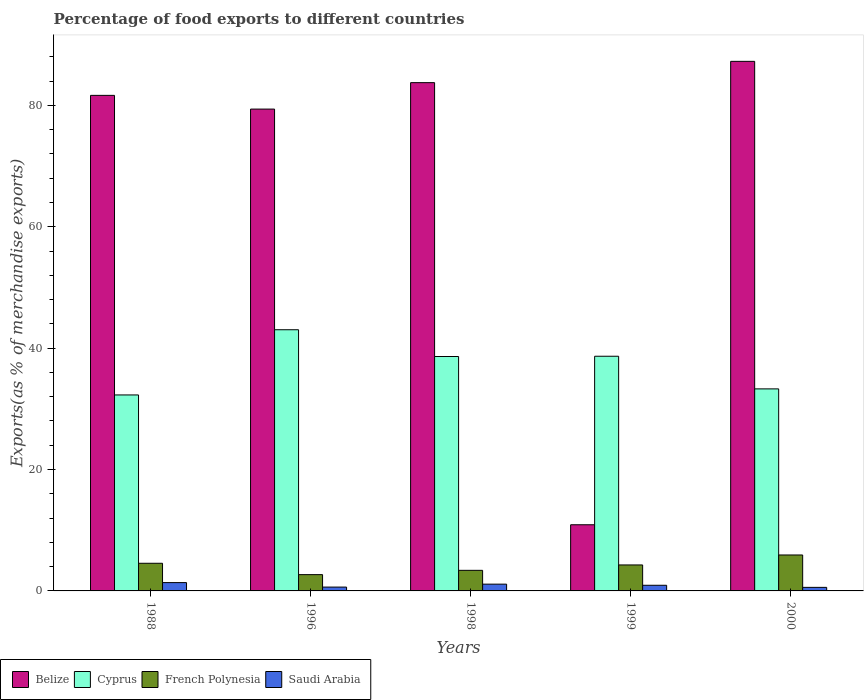How many groups of bars are there?
Provide a short and direct response. 5. Are the number of bars on each tick of the X-axis equal?
Provide a succinct answer. Yes. How many bars are there on the 4th tick from the left?
Make the answer very short. 4. How many bars are there on the 2nd tick from the right?
Provide a succinct answer. 4. What is the label of the 5th group of bars from the left?
Your response must be concise. 2000. What is the percentage of exports to different countries in Cyprus in 1998?
Ensure brevity in your answer.  38.62. Across all years, what is the maximum percentage of exports to different countries in Saudi Arabia?
Ensure brevity in your answer.  1.37. Across all years, what is the minimum percentage of exports to different countries in French Polynesia?
Make the answer very short. 2.68. In which year was the percentage of exports to different countries in Saudi Arabia maximum?
Your answer should be very brief. 1988. In which year was the percentage of exports to different countries in Saudi Arabia minimum?
Offer a very short reply. 2000. What is the total percentage of exports to different countries in Cyprus in the graph?
Your response must be concise. 185.91. What is the difference between the percentage of exports to different countries in Saudi Arabia in 1998 and that in 2000?
Your response must be concise. 0.53. What is the difference between the percentage of exports to different countries in French Polynesia in 1988 and the percentage of exports to different countries in Cyprus in 1998?
Keep it short and to the point. -34.07. What is the average percentage of exports to different countries in Belize per year?
Keep it short and to the point. 68.59. In the year 2000, what is the difference between the percentage of exports to different countries in French Polynesia and percentage of exports to different countries in Cyprus?
Ensure brevity in your answer.  -27.37. In how many years, is the percentage of exports to different countries in Belize greater than 80 %?
Make the answer very short. 3. What is the ratio of the percentage of exports to different countries in Saudi Arabia in 1988 to that in 1998?
Ensure brevity in your answer.  1.23. Is the difference between the percentage of exports to different countries in French Polynesia in 1998 and 1999 greater than the difference between the percentage of exports to different countries in Cyprus in 1998 and 1999?
Ensure brevity in your answer.  No. What is the difference between the highest and the second highest percentage of exports to different countries in Cyprus?
Keep it short and to the point. 4.37. What is the difference between the highest and the lowest percentage of exports to different countries in Saudi Arabia?
Your answer should be compact. 0.78. In how many years, is the percentage of exports to different countries in Saudi Arabia greater than the average percentage of exports to different countries in Saudi Arabia taken over all years?
Your answer should be compact. 3. Is the sum of the percentage of exports to different countries in Cyprus in 1988 and 1998 greater than the maximum percentage of exports to different countries in Saudi Arabia across all years?
Make the answer very short. Yes. What does the 4th bar from the left in 1996 represents?
Your answer should be very brief. Saudi Arabia. What does the 2nd bar from the right in 1988 represents?
Keep it short and to the point. French Polynesia. Is it the case that in every year, the sum of the percentage of exports to different countries in Saudi Arabia and percentage of exports to different countries in French Polynesia is greater than the percentage of exports to different countries in Belize?
Your answer should be compact. No. How many bars are there?
Provide a short and direct response. 20. Are all the bars in the graph horizontal?
Provide a succinct answer. No. How many years are there in the graph?
Your response must be concise. 5. Does the graph contain any zero values?
Make the answer very short. No. Does the graph contain grids?
Offer a terse response. No. Where does the legend appear in the graph?
Provide a succinct answer. Bottom left. How many legend labels are there?
Your answer should be compact. 4. How are the legend labels stacked?
Your response must be concise. Horizontal. What is the title of the graph?
Offer a very short reply. Percentage of food exports to different countries. Does "Arab World" appear as one of the legend labels in the graph?
Make the answer very short. No. What is the label or title of the X-axis?
Offer a terse response. Years. What is the label or title of the Y-axis?
Ensure brevity in your answer.  Exports(as % of merchandise exports). What is the Exports(as % of merchandise exports) in Belize in 1988?
Keep it short and to the point. 81.65. What is the Exports(as % of merchandise exports) in Cyprus in 1988?
Offer a terse response. 32.29. What is the Exports(as % of merchandise exports) in French Polynesia in 1988?
Your answer should be very brief. 4.56. What is the Exports(as % of merchandise exports) of Saudi Arabia in 1988?
Your response must be concise. 1.37. What is the Exports(as % of merchandise exports) of Belize in 1996?
Your answer should be very brief. 79.39. What is the Exports(as % of merchandise exports) in Cyprus in 1996?
Make the answer very short. 43.04. What is the Exports(as % of merchandise exports) of French Polynesia in 1996?
Provide a succinct answer. 2.68. What is the Exports(as % of merchandise exports) of Saudi Arabia in 1996?
Your answer should be compact. 0.63. What is the Exports(as % of merchandise exports) in Belize in 1998?
Offer a terse response. 83.75. What is the Exports(as % of merchandise exports) in Cyprus in 1998?
Your answer should be very brief. 38.62. What is the Exports(as % of merchandise exports) of French Polynesia in 1998?
Make the answer very short. 3.39. What is the Exports(as % of merchandise exports) of Saudi Arabia in 1998?
Offer a very short reply. 1.11. What is the Exports(as % of merchandise exports) in Belize in 1999?
Your answer should be very brief. 10.9. What is the Exports(as % of merchandise exports) of Cyprus in 1999?
Offer a very short reply. 38.67. What is the Exports(as % of merchandise exports) of French Polynesia in 1999?
Give a very brief answer. 4.28. What is the Exports(as % of merchandise exports) in Saudi Arabia in 1999?
Keep it short and to the point. 0.93. What is the Exports(as % of merchandise exports) of Belize in 2000?
Keep it short and to the point. 87.26. What is the Exports(as % of merchandise exports) in Cyprus in 2000?
Make the answer very short. 33.29. What is the Exports(as % of merchandise exports) of French Polynesia in 2000?
Provide a succinct answer. 5.92. What is the Exports(as % of merchandise exports) in Saudi Arabia in 2000?
Give a very brief answer. 0.59. Across all years, what is the maximum Exports(as % of merchandise exports) of Belize?
Ensure brevity in your answer.  87.26. Across all years, what is the maximum Exports(as % of merchandise exports) in Cyprus?
Your answer should be compact. 43.04. Across all years, what is the maximum Exports(as % of merchandise exports) in French Polynesia?
Give a very brief answer. 5.92. Across all years, what is the maximum Exports(as % of merchandise exports) of Saudi Arabia?
Your answer should be compact. 1.37. Across all years, what is the minimum Exports(as % of merchandise exports) in Belize?
Ensure brevity in your answer.  10.9. Across all years, what is the minimum Exports(as % of merchandise exports) of Cyprus?
Give a very brief answer. 32.29. Across all years, what is the minimum Exports(as % of merchandise exports) in French Polynesia?
Offer a terse response. 2.68. Across all years, what is the minimum Exports(as % of merchandise exports) of Saudi Arabia?
Keep it short and to the point. 0.59. What is the total Exports(as % of merchandise exports) of Belize in the graph?
Offer a terse response. 342.96. What is the total Exports(as % of merchandise exports) in Cyprus in the graph?
Make the answer very short. 185.91. What is the total Exports(as % of merchandise exports) in French Polynesia in the graph?
Your answer should be compact. 20.84. What is the total Exports(as % of merchandise exports) in Saudi Arabia in the graph?
Make the answer very short. 4.64. What is the difference between the Exports(as % of merchandise exports) in Belize in 1988 and that in 1996?
Provide a short and direct response. 2.26. What is the difference between the Exports(as % of merchandise exports) of Cyprus in 1988 and that in 1996?
Give a very brief answer. -10.74. What is the difference between the Exports(as % of merchandise exports) of French Polynesia in 1988 and that in 1996?
Give a very brief answer. 1.87. What is the difference between the Exports(as % of merchandise exports) of Saudi Arabia in 1988 and that in 1996?
Your response must be concise. 0.74. What is the difference between the Exports(as % of merchandise exports) of Belize in 1988 and that in 1998?
Keep it short and to the point. -2.1. What is the difference between the Exports(as % of merchandise exports) of Cyprus in 1988 and that in 1998?
Your answer should be compact. -6.33. What is the difference between the Exports(as % of merchandise exports) of French Polynesia in 1988 and that in 1998?
Offer a very short reply. 1.16. What is the difference between the Exports(as % of merchandise exports) in Saudi Arabia in 1988 and that in 1998?
Provide a short and direct response. 0.26. What is the difference between the Exports(as % of merchandise exports) in Belize in 1988 and that in 1999?
Your response must be concise. 70.75. What is the difference between the Exports(as % of merchandise exports) in Cyprus in 1988 and that in 1999?
Make the answer very short. -6.38. What is the difference between the Exports(as % of merchandise exports) in French Polynesia in 1988 and that in 1999?
Give a very brief answer. 0.27. What is the difference between the Exports(as % of merchandise exports) in Saudi Arabia in 1988 and that in 1999?
Make the answer very short. 0.44. What is the difference between the Exports(as % of merchandise exports) of Belize in 1988 and that in 2000?
Ensure brevity in your answer.  -5.61. What is the difference between the Exports(as % of merchandise exports) of Cyprus in 1988 and that in 2000?
Offer a very short reply. -1. What is the difference between the Exports(as % of merchandise exports) of French Polynesia in 1988 and that in 2000?
Offer a very short reply. -1.37. What is the difference between the Exports(as % of merchandise exports) in Saudi Arabia in 1988 and that in 2000?
Provide a succinct answer. 0.78. What is the difference between the Exports(as % of merchandise exports) in Belize in 1996 and that in 1998?
Give a very brief answer. -4.36. What is the difference between the Exports(as % of merchandise exports) of Cyprus in 1996 and that in 1998?
Offer a terse response. 4.41. What is the difference between the Exports(as % of merchandise exports) in French Polynesia in 1996 and that in 1998?
Your answer should be compact. -0.71. What is the difference between the Exports(as % of merchandise exports) in Saudi Arabia in 1996 and that in 1998?
Make the answer very short. -0.48. What is the difference between the Exports(as % of merchandise exports) of Belize in 1996 and that in 1999?
Give a very brief answer. 68.49. What is the difference between the Exports(as % of merchandise exports) in Cyprus in 1996 and that in 1999?
Your response must be concise. 4.37. What is the difference between the Exports(as % of merchandise exports) of French Polynesia in 1996 and that in 1999?
Offer a very short reply. -1.6. What is the difference between the Exports(as % of merchandise exports) in Saudi Arabia in 1996 and that in 1999?
Keep it short and to the point. -0.3. What is the difference between the Exports(as % of merchandise exports) of Belize in 1996 and that in 2000?
Make the answer very short. -7.87. What is the difference between the Exports(as % of merchandise exports) of Cyprus in 1996 and that in 2000?
Provide a succinct answer. 9.74. What is the difference between the Exports(as % of merchandise exports) of French Polynesia in 1996 and that in 2000?
Provide a short and direct response. -3.24. What is the difference between the Exports(as % of merchandise exports) in Saudi Arabia in 1996 and that in 2000?
Your answer should be compact. 0.05. What is the difference between the Exports(as % of merchandise exports) of Belize in 1998 and that in 1999?
Offer a terse response. 72.85. What is the difference between the Exports(as % of merchandise exports) in Cyprus in 1998 and that in 1999?
Your response must be concise. -0.05. What is the difference between the Exports(as % of merchandise exports) in French Polynesia in 1998 and that in 1999?
Make the answer very short. -0.89. What is the difference between the Exports(as % of merchandise exports) in Saudi Arabia in 1998 and that in 1999?
Provide a succinct answer. 0.18. What is the difference between the Exports(as % of merchandise exports) of Belize in 1998 and that in 2000?
Your answer should be very brief. -3.51. What is the difference between the Exports(as % of merchandise exports) in Cyprus in 1998 and that in 2000?
Provide a short and direct response. 5.33. What is the difference between the Exports(as % of merchandise exports) in French Polynesia in 1998 and that in 2000?
Ensure brevity in your answer.  -2.53. What is the difference between the Exports(as % of merchandise exports) of Saudi Arabia in 1998 and that in 2000?
Keep it short and to the point. 0.53. What is the difference between the Exports(as % of merchandise exports) of Belize in 1999 and that in 2000?
Provide a succinct answer. -76.36. What is the difference between the Exports(as % of merchandise exports) in Cyprus in 1999 and that in 2000?
Provide a short and direct response. 5.38. What is the difference between the Exports(as % of merchandise exports) of French Polynesia in 1999 and that in 2000?
Provide a short and direct response. -1.64. What is the difference between the Exports(as % of merchandise exports) of Saudi Arabia in 1999 and that in 2000?
Your answer should be very brief. 0.34. What is the difference between the Exports(as % of merchandise exports) of Belize in 1988 and the Exports(as % of merchandise exports) of Cyprus in 1996?
Your response must be concise. 38.62. What is the difference between the Exports(as % of merchandise exports) of Belize in 1988 and the Exports(as % of merchandise exports) of French Polynesia in 1996?
Ensure brevity in your answer.  78.97. What is the difference between the Exports(as % of merchandise exports) of Belize in 1988 and the Exports(as % of merchandise exports) of Saudi Arabia in 1996?
Keep it short and to the point. 81.02. What is the difference between the Exports(as % of merchandise exports) in Cyprus in 1988 and the Exports(as % of merchandise exports) in French Polynesia in 1996?
Your response must be concise. 29.61. What is the difference between the Exports(as % of merchandise exports) of Cyprus in 1988 and the Exports(as % of merchandise exports) of Saudi Arabia in 1996?
Your answer should be compact. 31.66. What is the difference between the Exports(as % of merchandise exports) in French Polynesia in 1988 and the Exports(as % of merchandise exports) in Saudi Arabia in 1996?
Keep it short and to the point. 3.92. What is the difference between the Exports(as % of merchandise exports) of Belize in 1988 and the Exports(as % of merchandise exports) of Cyprus in 1998?
Your answer should be compact. 43.03. What is the difference between the Exports(as % of merchandise exports) in Belize in 1988 and the Exports(as % of merchandise exports) in French Polynesia in 1998?
Offer a very short reply. 78.26. What is the difference between the Exports(as % of merchandise exports) of Belize in 1988 and the Exports(as % of merchandise exports) of Saudi Arabia in 1998?
Your answer should be compact. 80.54. What is the difference between the Exports(as % of merchandise exports) of Cyprus in 1988 and the Exports(as % of merchandise exports) of French Polynesia in 1998?
Offer a very short reply. 28.9. What is the difference between the Exports(as % of merchandise exports) in Cyprus in 1988 and the Exports(as % of merchandise exports) in Saudi Arabia in 1998?
Ensure brevity in your answer.  31.18. What is the difference between the Exports(as % of merchandise exports) in French Polynesia in 1988 and the Exports(as % of merchandise exports) in Saudi Arabia in 1998?
Offer a very short reply. 3.44. What is the difference between the Exports(as % of merchandise exports) of Belize in 1988 and the Exports(as % of merchandise exports) of Cyprus in 1999?
Offer a very short reply. 42.98. What is the difference between the Exports(as % of merchandise exports) of Belize in 1988 and the Exports(as % of merchandise exports) of French Polynesia in 1999?
Make the answer very short. 77.37. What is the difference between the Exports(as % of merchandise exports) of Belize in 1988 and the Exports(as % of merchandise exports) of Saudi Arabia in 1999?
Your answer should be compact. 80.72. What is the difference between the Exports(as % of merchandise exports) in Cyprus in 1988 and the Exports(as % of merchandise exports) in French Polynesia in 1999?
Provide a short and direct response. 28.01. What is the difference between the Exports(as % of merchandise exports) in Cyprus in 1988 and the Exports(as % of merchandise exports) in Saudi Arabia in 1999?
Your answer should be compact. 31.36. What is the difference between the Exports(as % of merchandise exports) of French Polynesia in 1988 and the Exports(as % of merchandise exports) of Saudi Arabia in 1999?
Your answer should be compact. 3.62. What is the difference between the Exports(as % of merchandise exports) in Belize in 1988 and the Exports(as % of merchandise exports) in Cyprus in 2000?
Keep it short and to the point. 48.36. What is the difference between the Exports(as % of merchandise exports) in Belize in 1988 and the Exports(as % of merchandise exports) in French Polynesia in 2000?
Your response must be concise. 75.73. What is the difference between the Exports(as % of merchandise exports) in Belize in 1988 and the Exports(as % of merchandise exports) in Saudi Arabia in 2000?
Your answer should be compact. 81.07. What is the difference between the Exports(as % of merchandise exports) of Cyprus in 1988 and the Exports(as % of merchandise exports) of French Polynesia in 2000?
Keep it short and to the point. 26.37. What is the difference between the Exports(as % of merchandise exports) in Cyprus in 1988 and the Exports(as % of merchandise exports) in Saudi Arabia in 2000?
Your response must be concise. 31.71. What is the difference between the Exports(as % of merchandise exports) of French Polynesia in 1988 and the Exports(as % of merchandise exports) of Saudi Arabia in 2000?
Ensure brevity in your answer.  3.97. What is the difference between the Exports(as % of merchandise exports) in Belize in 1996 and the Exports(as % of merchandise exports) in Cyprus in 1998?
Your answer should be very brief. 40.77. What is the difference between the Exports(as % of merchandise exports) in Belize in 1996 and the Exports(as % of merchandise exports) in French Polynesia in 1998?
Provide a short and direct response. 76. What is the difference between the Exports(as % of merchandise exports) in Belize in 1996 and the Exports(as % of merchandise exports) in Saudi Arabia in 1998?
Provide a succinct answer. 78.28. What is the difference between the Exports(as % of merchandise exports) of Cyprus in 1996 and the Exports(as % of merchandise exports) of French Polynesia in 1998?
Ensure brevity in your answer.  39.64. What is the difference between the Exports(as % of merchandise exports) in Cyprus in 1996 and the Exports(as % of merchandise exports) in Saudi Arabia in 1998?
Make the answer very short. 41.92. What is the difference between the Exports(as % of merchandise exports) of French Polynesia in 1996 and the Exports(as % of merchandise exports) of Saudi Arabia in 1998?
Keep it short and to the point. 1.57. What is the difference between the Exports(as % of merchandise exports) of Belize in 1996 and the Exports(as % of merchandise exports) of Cyprus in 1999?
Provide a short and direct response. 40.72. What is the difference between the Exports(as % of merchandise exports) of Belize in 1996 and the Exports(as % of merchandise exports) of French Polynesia in 1999?
Provide a succinct answer. 75.11. What is the difference between the Exports(as % of merchandise exports) in Belize in 1996 and the Exports(as % of merchandise exports) in Saudi Arabia in 1999?
Your response must be concise. 78.46. What is the difference between the Exports(as % of merchandise exports) in Cyprus in 1996 and the Exports(as % of merchandise exports) in French Polynesia in 1999?
Provide a short and direct response. 38.75. What is the difference between the Exports(as % of merchandise exports) of Cyprus in 1996 and the Exports(as % of merchandise exports) of Saudi Arabia in 1999?
Your answer should be compact. 42.1. What is the difference between the Exports(as % of merchandise exports) in French Polynesia in 1996 and the Exports(as % of merchandise exports) in Saudi Arabia in 1999?
Ensure brevity in your answer.  1.75. What is the difference between the Exports(as % of merchandise exports) of Belize in 1996 and the Exports(as % of merchandise exports) of Cyprus in 2000?
Give a very brief answer. 46.1. What is the difference between the Exports(as % of merchandise exports) of Belize in 1996 and the Exports(as % of merchandise exports) of French Polynesia in 2000?
Make the answer very short. 73.47. What is the difference between the Exports(as % of merchandise exports) of Belize in 1996 and the Exports(as % of merchandise exports) of Saudi Arabia in 2000?
Keep it short and to the point. 78.81. What is the difference between the Exports(as % of merchandise exports) of Cyprus in 1996 and the Exports(as % of merchandise exports) of French Polynesia in 2000?
Give a very brief answer. 37.11. What is the difference between the Exports(as % of merchandise exports) of Cyprus in 1996 and the Exports(as % of merchandise exports) of Saudi Arabia in 2000?
Your answer should be compact. 42.45. What is the difference between the Exports(as % of merchandise exports) in French Polynesia in 1996 and the Exports(as % of merchandise exports) in Saudi Arabia in 2000?
Provide a short and direct response. 2.1. What is the difference between the Exports(as % of merchandise exports) in Belize in 1998 and the Exports(as % of merchandise exports) in Cyprus in 1999?
Your answer should be compact. 45.08. What is the difference between the Exports(as % of merchandise exports) in Belize in 1998 and the Exports(as % of merchandise exports) in French Polynesia in 1999?
Your answer should be very brief. 79.47. What is the difference between the Exports(as % of merchandise exports) in Belize in 1998 and the Exports(as % of merchandise exports) in Saudi Arabia in 1999?
Offer a terse response. 82.82. What is the difference between the Exports(as % of merchandise exports) of Cyprus in 1998 and the Exports(as % of merchandise exports) of French Polynesia in 1999?
Offer a very short reply. 34.34. What is the difference between the Exports(as % of merchandise exports) in Cyprus in 1998 and the Exports(as % of merchandise exports) in Saudi Arabia in 1999?
Provide a succinct answer. 37.69. What is the difference between the Exports(as % of merchandise exports) of French Polynesia in 1998 and the Exports(as % of merchandise exports) of Saudi Arabia in 1999?
Your answer should be compact. 2.46. What is the difference between the Exports(as % of merchandise exports) in Belize in 1998 and the Exports(as % of merchandise exports) in Cyprus in 2000?
Keep it short and to the point. 50.46. What is the difference between the Exports(as % of merchandise exports) of Belize in 1998 and the Exports(as % of merchandise exports) of French Polynesia in 2000?
Offer a terse response. 77.83. What is the difference between the Exports(as % of merchandise exports) of Belize in 1998 and the Exports(as % of merchandise exports) of Saudi Arabia in 2000?
Provide a succinct answer. 83.16. What is the difference between the Exports(as % of merchandise exports) in Cyprus in 1998 and the Exports(as % of merchandise exports) in French Polynesia in 2000?
Your answer should be very brief. 32.7. What is the difference between the Exports(as % of merchandise exports) in Cyprus in 1998 and the Exports(as % of merchandise exports) in Saudi Arabia in 2000?
Provide a succinct answer. 38.04. What is the difference between the Exports(as % of merchandise exports) of French Polynesia in 1998 and the Exports(as % of merchandise exports) of Saudi Arabia in 2000?
Make the answer very short. 2.81. What is the difference between the Exports(as % of merchandise exports) of Belize in 1999 and the Exports(as % of merchandise exports) of Cyprus in 2000?
Your answer should be compact. -22.39. What is the difference between the Exports(as % of merchandise exports) of Belize in 1999 and the Exports(as % of merchandise exports) of French Polynesia in 2000?
Ensure brevity in your answer.  4.98. What is the difference between the Exports(as % of merchandise exports) in Belize in 1999 and the Exports(as % of merchandise exports) in Saudi Arabia in 2000?
Ensure brevity in your answer.  10.32. What is the difference between the Exports(as % of merchandise exports) of Cyprus in 1999 and the Exports(as % of merchandise exports) of French Polynesia in 2000?
Keep it short and to the point. 32.75. What is the difference between the Exports(as % of merchandise exports) in Cyprus in 1999 and the Exports(as % of merchandise exports) in Saudi Arabia in 2000?
Your answer should be compact. 38.08. What is the difference between the Exports(as % of merchandise exports) of French Polynesia in 1999 and the Exports(as % of merchandise exports) of Saudi Arabia in 2000?
Provide a succinct answer. 3.69. What is the average Exports(as % of merchandise exports) of Belize per year?
Keep it short and to the point. 68.59. What is the average Exports(as % of merchandise exports) of Cyprus per year?
Provide a succinct answer. 37.18. What is the average Exports(as % of merchandise exports) in French Polynesia per year?
Offer a terse response. 4.17. What is the average Exports(as % of merchandise exports) in Saudi Arabia per year?
Give a very brief answer. 0.93. In the year 1988, what is the difference between the Exports(as % of merchandise exports) in Belize and Exports(as % of merchandise exports) in Cyprus?
Provide a short and direct response. 49.36. In the year 1988, what is the difference between the Exports(as % of merchandise exports) in Belize and Exports(as % of merchandise exports) in French Polynesia?
Make the answer very short. 77.1. In the year 1988, what is the difference between the Exports(as % of merchandise exports) of Belize and Exports(as % of merchandise exports) of Saudi Arabia?
Provide a succinct answer. 80.28. In the year 1988, what is the difference between the Exports(as % of merchandise exports) in Cyprus and Exports(as % of merchandise exports) in French Polynesia?
Make the answer very short. 27.74. In the year 1988, what is the difference between the Exports(as % of merchandise exports) of Cyprus and Exports(as % of merchandise exports) of Saudi Arabia?
Make the answer very short. 30.92. In the year 1988, what is the difference between the Exports(as % of merchandise exports) of French Polynesia and Exports(as % of merchandise exports) of Saudi Arabia?
Your answer should be very brief. 3.18. In the year 1996, what is the difference between the Exports(as % of merchandise exports) in Belize and Exports(as % of merchandise exports) in Cyprus?
Your answer should be very brief. 36.36. In the year 1996, what is the difference between the Exports(as % of merchandise exports) of Belize and Exports(as % of merchandise exports) of French Polynesia?
Provide a short and direct response. 76.71. In the year 1996, what is the difference between the Exports(as % of merchandise exports) of Belize and Exports(as % of merchandise exports) of Saudi Arabia?
Give a very brief answer. 78.76. In the year 1996, what is the difference between the Exports(as % of merchandise exports) in Cyprus and Exports(as % of merchandise exports) in French Polynesia?
Keep it short and to the point. 40.35. In the year 1996, what is the difference between the Exports(as % of merchandise exports) of Cyprus and Exports(as % of merchandise exports) of Saudi Arabia?
Provide a short and direct response. 42.4. In the year 1996, what is the difference between the Exports(as % of merchandise exports) of French Polynesia and Exports(as % of merchandise exports) of Saudi Arabia?
Offer a very short reply. 2.05. In the year 1998, what is the difference between the Exports(as % of merchandise exports) of Belize and Exports(as % of merchandise exports) of Cyprus?
Offer a very short reply. 45.12. In the year 1998, what is the difference between the Exports(as % of merchandise exports) of Belize and Exports(as % of merchandise exports) of French Polynesia?
Provide a short and direct response. 80.36. In the year 1998, what is the difference between the Exports(as % of merchandise exports) of Belize and Exports(as % of merchandise exports) of Saudi Arabia?
Your response must be concise. 82.63. In the year 1998, what is the difference between the Exports(as % of merchandise exports) of Cyprus and Exports(as % of merchandise exports) of French Polynesia?
Your answer should be compact. 35.23. In the year 1998, what is the difference between the Exports(as % of merchandise exports) in Cyprus and Exports(as % of merchandise exports) in Saudi Arabia?
Provide a short and direct response. 37.51. In the year 1998, what is the difference between the Exports(as % of merchandise exports) of French Polynesia and Exports(as % of merchandise exports) of Saudi Arabia?
Offer a terse response. 2.28. In the year 1999, what is the difference between the Exports(as % of merchandise exports) of Belize and Exports(as % of merchandise exports) of Cyprus?
Your answer should be compact. -27.77. In the year 1999, what is the difference between the Exports(as % of merchandise exports) of Belize and Exports(as % of merchandise exports) of French Polynesia?
Your response must be concise. 6.62. In the year 1999, what is the difference between the Exports(as % of merchandise exports) in Belize and Exports(as % of merchandise exports) in Saudi Arabia?
Provide a succinct answer. 9.97. In the year 1999, what is the difference between the Exports(as % of merchandise exports) in Cyprus and Exports(as % of merchandise exports) in French Polynesia?
Your answer should be compact. 34.39. In the year 1999, what is the difference between the Exports(as % of merchandise exports) in Cyprus and Exports(as % of merchandise exports) in Saudi Arabia?
Your answer should be compact. 37.74. In the year 1999, what is the difference between the Exports(as % of merchandise exports) of French Polynesia and Exports(as % of merchandise exports) of Saudi Arabia?
Your answer should be compact. 3.35. In the year 2000, what is the difference between the Exports(as % of merchandise exports) in Belize and Exports(as % of merchandise exports) in Cyprus?
Provide a short and direct response. 53.97. In the year 2000, what is the difference between the Exports(as % of merchandise exports) of Belize and Exports(as % of merchandise exports) of French Polynesia?
Offer a terse response. 81.34. In the year 2000, what is the difference between the Exports(as % of merchandise exports) in Belize and Exports(as % of merchandise exports) in Saudi Arabia?
Ensure brevity in your answer.  86.67. In the year 2000, what is the difference between the Exports(as % of merchandise exports) of Cyprus and Exports(as % of merchandise exports) of French Polynesia?
Your response must be concise. 27.37. In the year 2000, what is the difference between the Exports(as % of merchandise exports) of Cyprus and Exports(as % of merchandise exports) of Saudi Arabia?
Provide a short and direct response. 32.7. In the year 2000, what is the difference between the Exports(as % of merchandise exports) of French Polynesia and Exports(as % of merchandise exports) of Saudi Arabia?
Provide a short and direct response. 5.34. What is the ratio of the Exports(as % of merchandise exports) of Belize in 1988 to that in 1996?
Ensure brevity in your answer.  1.03. What is the ratio of the Exports(as % of merchandise exports) of Cyprus in 1988 to that in 1996?
Give a very brief answer. 0.75. What is the ratio of the Exports(as % of merchandise exports) of French Polynesia in 1988 to that in 1996?
Provide a succinct answer. 1.7. What is the ratio of the Exports(as % of merchandise exports) in Saudi Arabia in 1988 to that in 1996?
Give a very brief answer. 2.17. What is the ratio of the Exports(as % of merchandise exports) of Cyprus in 1988 to that in 1998?
Your answer should be very brief. 0.84. What is the ratio of the Exports(as % of merchandise exports) of French Polynesia in 1988 to that in 1998?
Ensure brevity in your answer.  1.34. What is the ratio of the Exports(as % of merchandise exports) of Saudi Arabia in 1988 to that in 1998?
Offer a terse response. 1.23. What is the ratio of the Exports(as % of merchandise exports) of Belize in 1988 to that in 1999?
Your answer should be compact. 7.49. What is the ratio of the Exports(as % of merchandise exports) in Cyprus in 1988 to that in 1999?
Offer a very short reply. 0.84. What is the ratio of the Exports(as % of merchandise exports) in French Polynesia in 1988 to that in 1999?
Your answer should be compact. 1.06. What is the ratio of the Exports(as % of merchandise exports) of Saudi Arabia in 1988 to that in 1999?
Give a very brief answer. 1.47. What is the ratio of the Exports(as % of merchandise exports) of Belize in 1988 to that in 2000?
Make the answer very short. 0.94. What is the ratio of the Exports(as % of merchandise exports) of Cyprus in 1988 to that in 2000?
Provide a succinct answer. 0.97. What is the ratio of the Exports(as % of merchandise exports) in French Polynesia in 1988 to that in 2000?
Make the answer very short. 0.77. What is the ratio of the Exports(as % of merchandise exports) in Saudi Arabia in 1988 to that in 2000?
Ensure brevity in your answer.  2.34. What is the ratio of the Exports(as % of merchandise exports) of Belize in 1996 to that in 1998?
Offer a very short reply. 0.95. What is the ratio of the Exports(as % of merchandise exports) of Cyprus in 1996 to that in 1998?
Your response must be concise. 1.11. What is the ratio of the Exports(as % of merchandise exports) in French Polynesia in 1996 to that in 1998?
Offer a very short reply. 0.79. What is the ratio of the Exports(as % of merchandise exports) in Saudi Arabia in 1996 to that in 1998?
Provide a succinct answer. 0.57. What is the ratio of the Exports(as % of merchandise exports) of Belize in 1996 to that in 1999?
Make the answer very short. 7.28. What is the ratio of the Exports(as % of merchandise exports) in Cyprus in 1996 to that in 1999?
Make the answer very short. 1.11. What is the ratio of the Exports(as % of merchandise exports) of French Polynesia in 1996 to that in 1999?
Your answer should be compact. 0.63. What is the ratio of the Exports(as % of merchandise exports) of Saudi Arabia in 1996 to that in 1999?
Give a very brief answer. 0.68. What is the ratio of the Exports(as % of merchandise exports) in Belize in 1996 to that in 2000?
Offer a very short reply. 0.91. What is the ratio of the Exports(as % of merchandise exports) in Cyprus in 1996 to that in 2000?
Ensure brevity in your answer.  1.29. What is the ratio of the Exports(as % of merchandise exports) in French Polynesia in 1996 to that in 2000?
Your answer should be very brief. 0.45. What is the ratio of the Exports(as % of merchandise exports) in Saudi Arabia in 1996 to that in 2000?
Your response must be concise. 1.08. What is the ratio of the Exports(as % of merchandise exports) of Belize in 1998 to that in 1999?
Provide a succinct answer. 7.68. What is the ratio of the Exports(as % of merchandise exports) of French Polynesia in 1998 to that in 1999?
Provide a short and direct response. 0.79. What is the ratio of the Exports(as % of merchandise exports) of Saudi Arabia in 1998 to that in 1999?
Provide a short and direct response. 1.2. What is the ratio of the Exports(as % of merchandise exports) in Belize in 1998 to that in 2000?
Your response must be concise. 0.96. What is the ratio of the Exports(as % of merchandise exports) in Cyprus in 1998 to that in 2000?
Your answer should be very brief. 1.16. What is the ratio of the Exports(as % of merchandise exports) in French Polynesia in 1998 to that in 2000?
Offer a very short reply. 0.57. What is the ratio of the Exports(as % of merchandise exports) of Saudi Arabia in 1998 to that in 2000?
Provide a short and direct response. 1.9. What is the ratio of the Exports(as % of merchandise exports) in Belize in 1999 to that in 2000?
Keep it short and to the point. 0.12. What is the ratio of the Exports(as % of merchandise exports) of Cyprus in 1999 to that in 2000?
Ensure brevity in your answer.  1.16. What is the ratio of the Exports(as % of merchandise exports) in French Polynesia in 1999 to that in 2000?
Offer a terse response. 0.72. What is the ratio of the Exports(as % of merchandise exports) in Saudi Arabia in 1999 to that in 2000?
Keep it short and to the point. 1.59. What is the difference between the highest and the second highest Exports(as % of merchandise exports) in Belize?
Ensure brevity in your answer.  3.51. What is the difference between the highest and the second highest Exports(as % of merchandise exports) in Cyprus?
Your answer should be compact. 4.37. What is the difference between the highest and the second highest Exports(as % of merchandise exports) in French Polynesia?
Make the answer very short. 1.37. What is the difference between the highest and the second highest Exports(as % of merchandise exports) of Saudi Arabia?
Provide a short and direct response. 0.26. What is the difference between the highest and the lowest Exports(as % of merchandise exports) in Belize?
Your answer should be very brief. 76.36. What is the difference between the highest and the lowest Exports(as % of merchandise exports) of Cyprus?
Provide a succinct answer. 10.74. What is the difference between the highest and the lowest Exports(as % of merchandise exports) in French Polynesia?
Keep it short and to the point. 3.24. What is the difference between the highest and the lowest Exports(as % of merchandise exports) in Saudi Arabia?
Offer a very short reply. 0.78. 